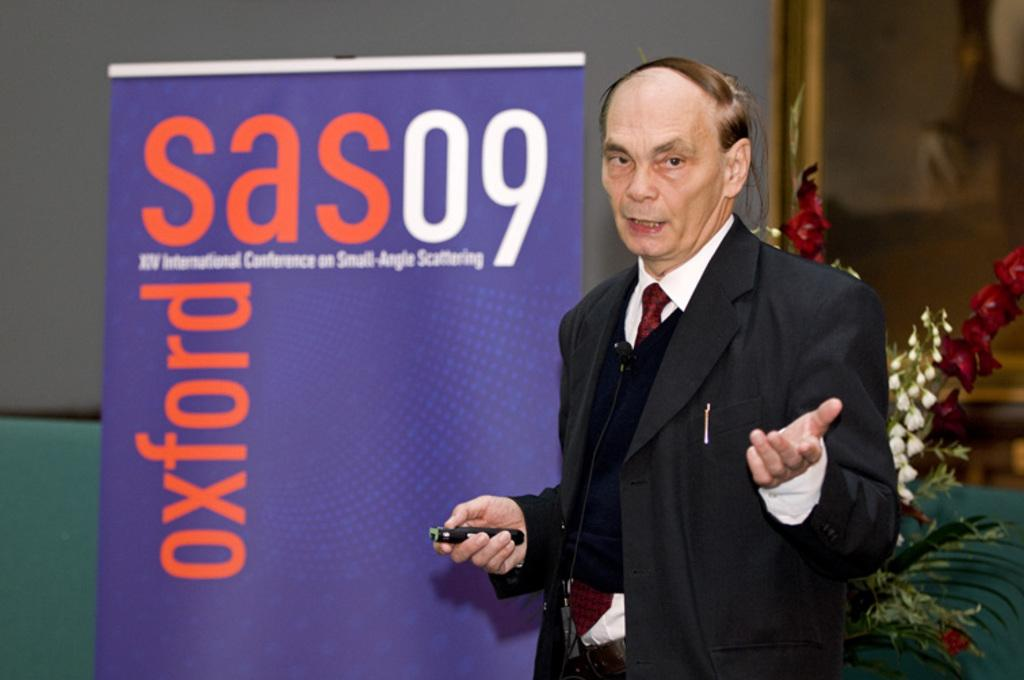What is the age of the person in the image? The person in the image is old. What is the old person wearing? The old person is wearing a suit. What is the old person holding? The old person is holding an object. What is the old person doing in the image? The old person is talking. What can be seen in the background of the image? There is a banner, a wall, a photo frame, and flowers in the background of the image. How many legs does the low form have in the image? There is no low form or legs present in the image. 